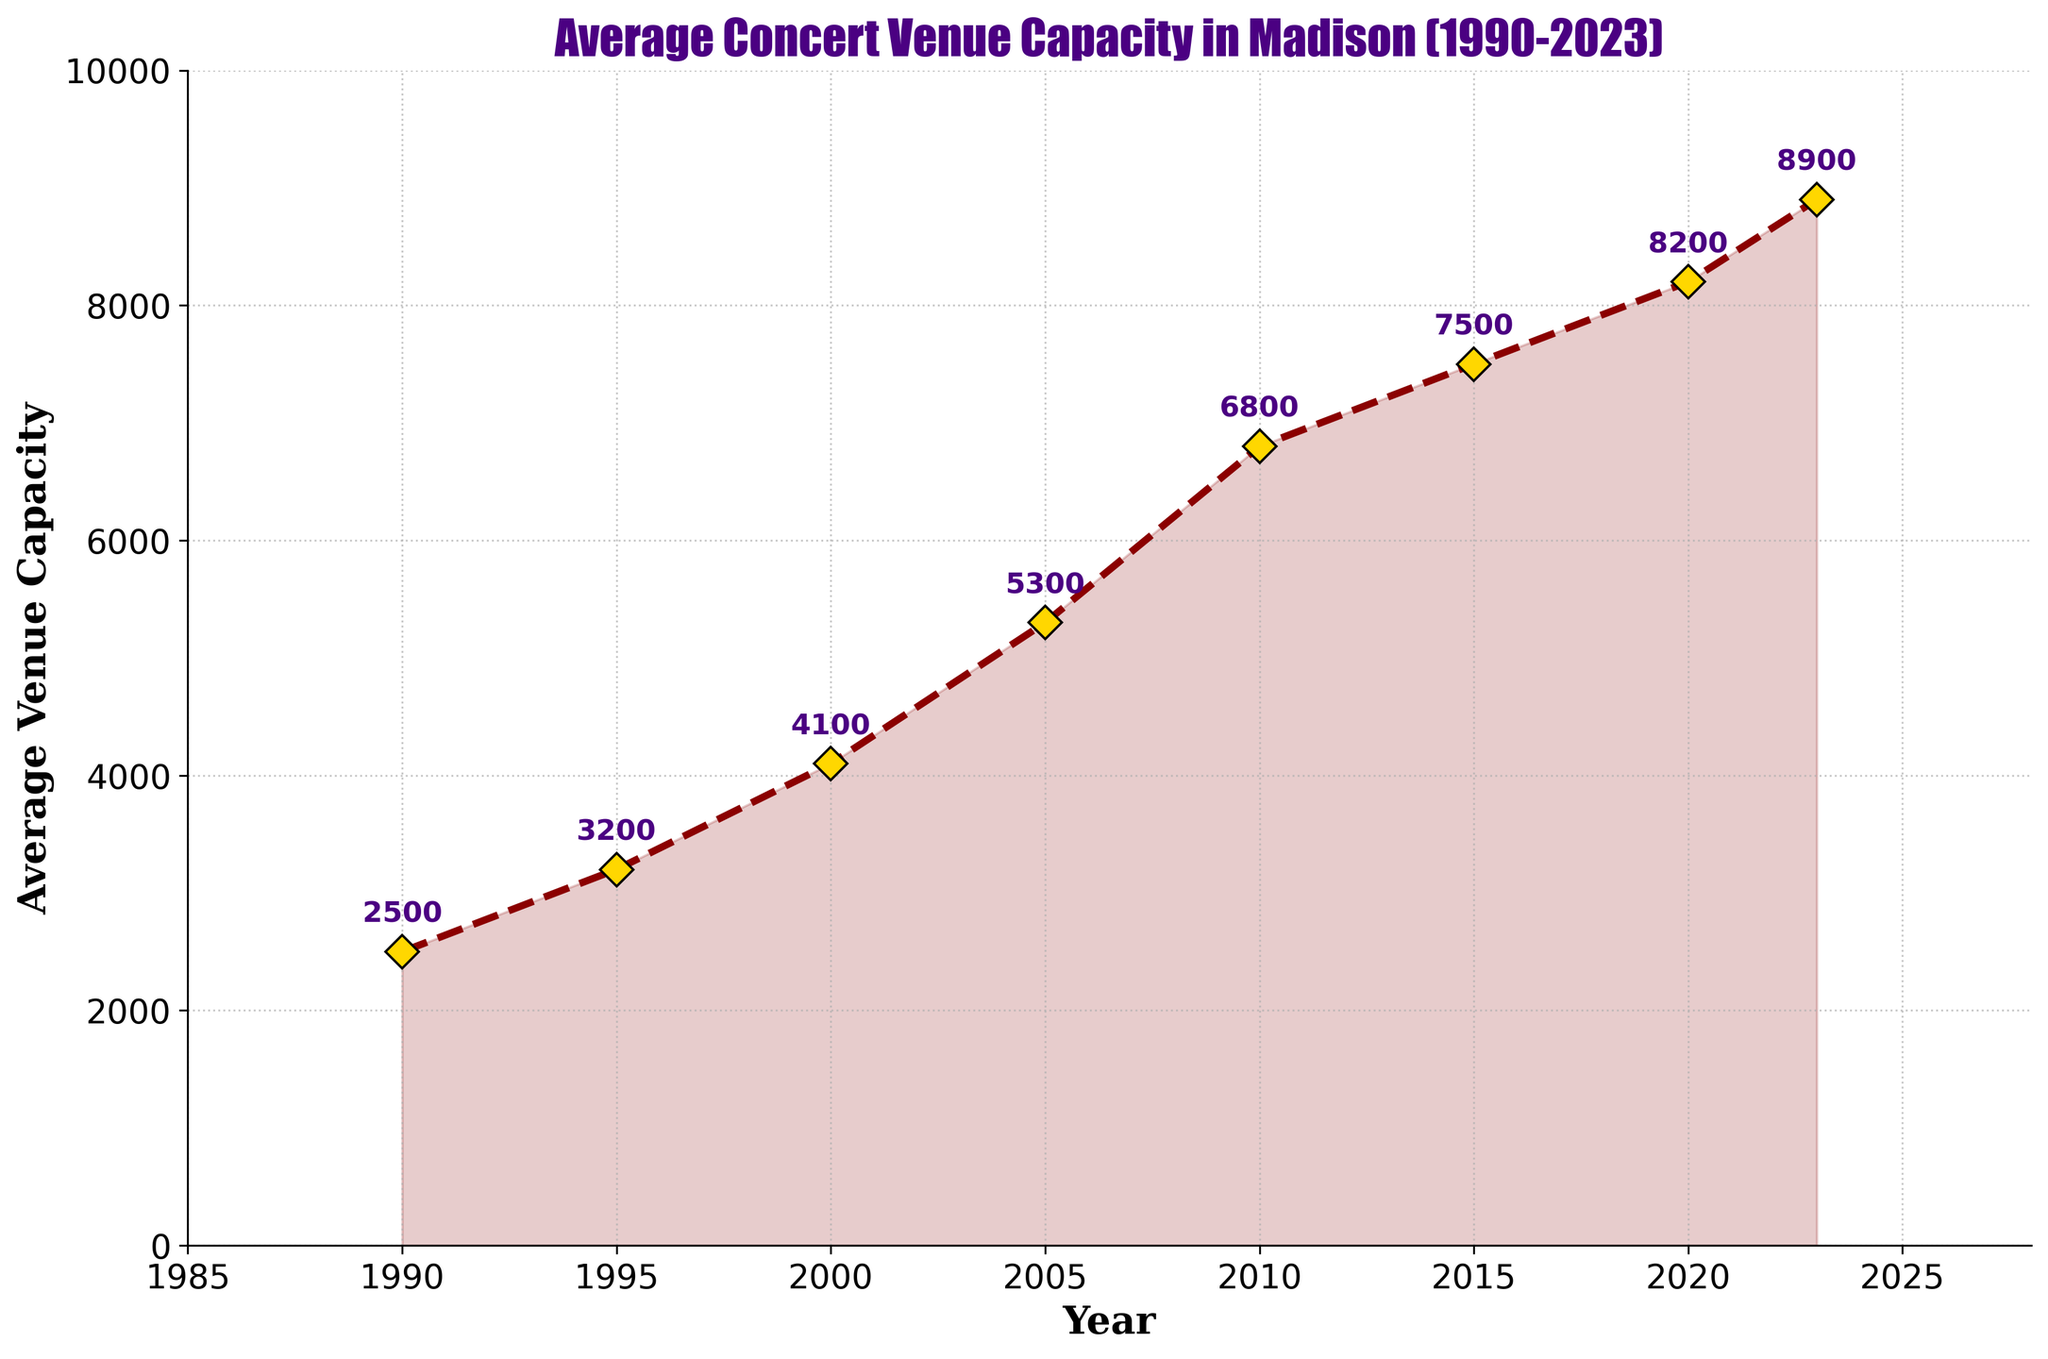What is the average venue capacity in Madison in the year 2000? By looking at the point corresponding to the year 2000 on the X-axis and its height on the Y-axis, we see the average venue capacity is 4100.
Answer: 4100 Between which years is there the largest increase in average venue capacity? Examining the differences between consecutive years, the largest increase is from 2005 to 2010, where the capacity increased from 5300 to 6800, a change of 1500.
Answer: 2005 to 2010 What is the overall trend in average venue capacity in Madison from 1990 to 2023? The average venue capacity shows an increasing trend from 1990 to 2023, with the capacity steadily rising over the entire period.
Answer: Increasing By how much did the average venue capacity change from 1990 to 2023? Subtract the capacity in 1990 (2500) from the capacity in 2023 (8900), which gives 8900 - 2500 = 6400.
Answer: 6400 How does the average venue capacity in 2020 compare to that in 2015? The capacity in 2020 (8200) is greater than in 2015 (7500) by 700.
Answer: 2020 is greater by 700 What decade saw a doubling of the venue capacity? The 1995 capacity (3200) roughly doubled by 2005 (5300) within the decade from 1995 to 2005.
Answer: 1995 to 2005 What value is annotated directly above the year 2005? The annotation above 2005 refers to the average capacity value of 5300.
Answer: 5300 How does the rate of increase from 2015 to 2020 compare to the rate from 2010 to 2015? From 2015 to 2020, the capacity increased from 7500 to 8200, a change of 700. From 2010 to 2015, it increased from 6800 to 7500, a change of 700. The rates are equal.
Answer: Rates are equal Which year corresponds to the lowest average venue capacity, and what is that capacity? The lowest capacity, according to the chart, is in 1990 with a value of 2500.
Answer: 1990, 2500 